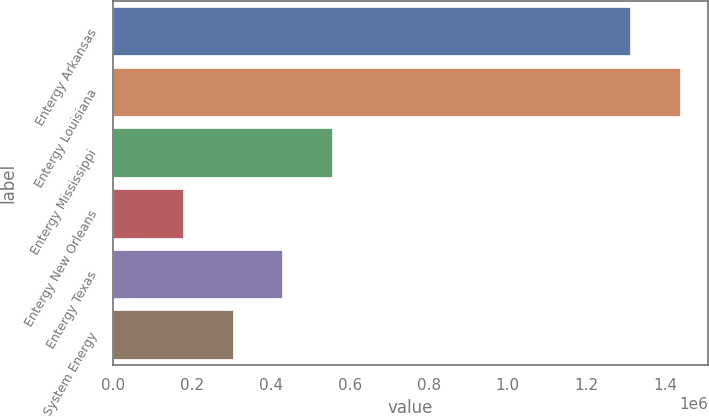<chart> <loc_0><loc_0><loc_500><loc_500><bar_chart><fcel>Entergy Arkansas<fcel>Entergy Louisiana<fcel>Entergy Mississippi<fcel>Entergy New Orleans<fcel>Entergy Texas<fcel>System Energy<nl><fcel>1.3099e+06<fcel>1.43654e+06<fcel>554645<fcel>176692<fcel>428661<fcel>302676<nl></chart> 